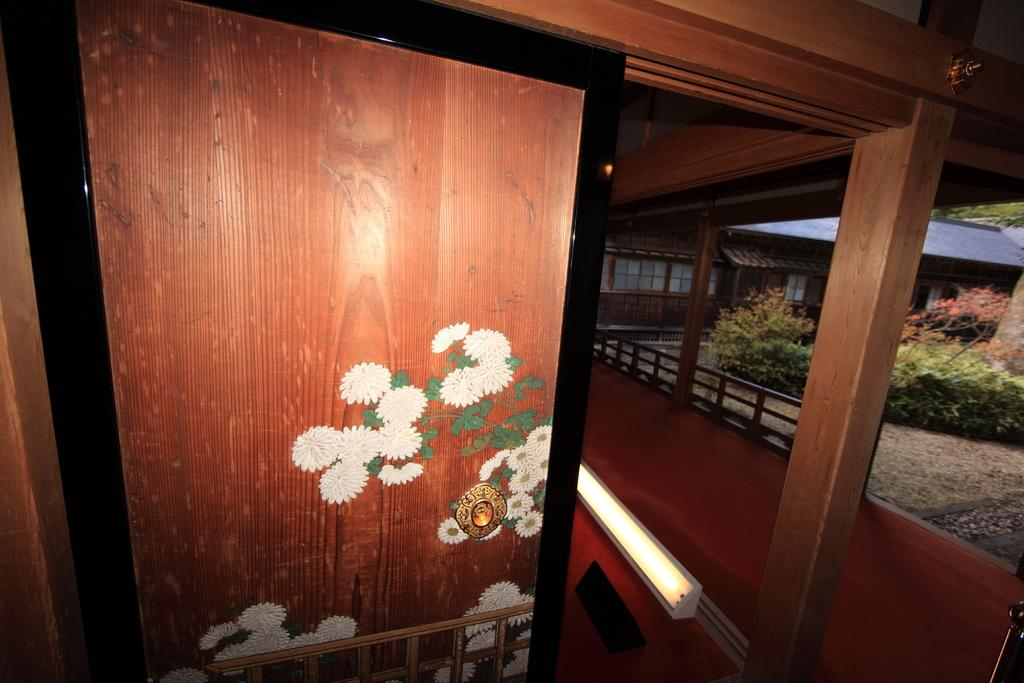What is located on the left side of the image? There is a door on the left side of the image. What can be seen on the right side of the image? There is railing on the right side of the image. What type of vegetation is visible in the background of the image? There are plants and trees in the background of the image. What type of sofa can be seen in the image? There is no sofa present in the image. What operation is being performed on the door in the image? There is no operation being performed on the door in the image; it is simply a stationary door. 